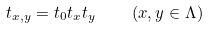<formula> <loc_0><loc_0><loc_500><loc_500>t _ { x , y } = t _ { 0 } t _ { x } t _ { y } \quad ( x , y \in \Lambda )</formula> 